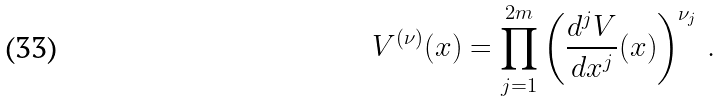Convert formula to latex. <formula><loc_0><loc_0><loc_500><loc_500>V ^ { ( \nu ) } ( x ) = \prod _ { j = 1 } ^ { 2 m } \left ( \frac { d ^ { j } V } { d x ^ { j } } ( x ) \right ) ^ { \nu _ { j } } \, .</formula> 